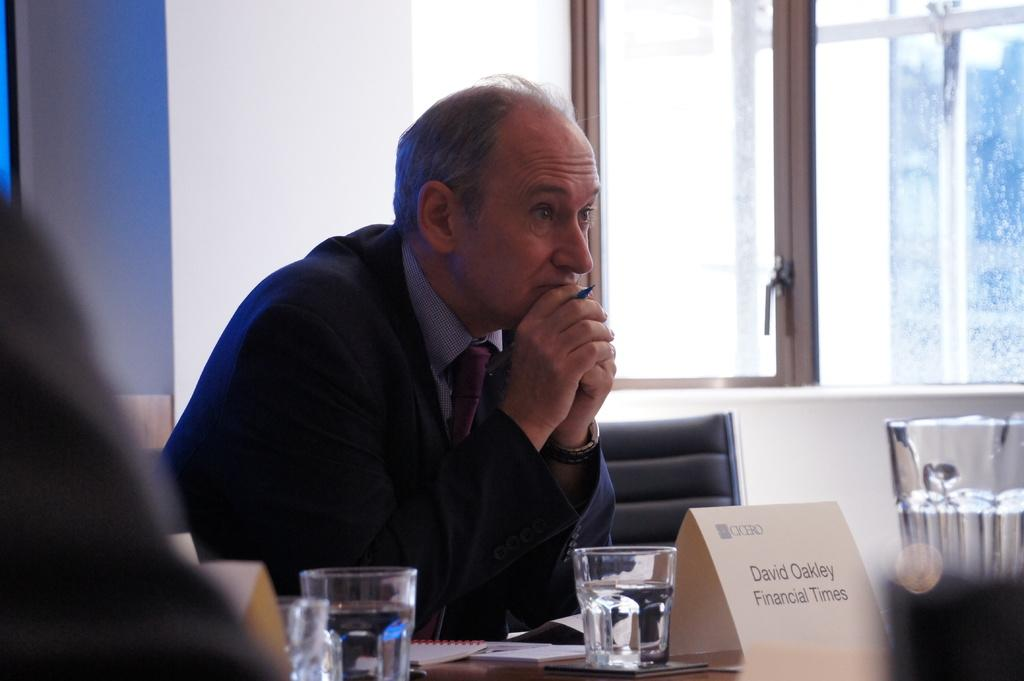<image>
Relay a brief, clear account of the picture shown. David Oakley looks very serious sitting at a conference table with a pen in his hand and a glass of water in front of him. 